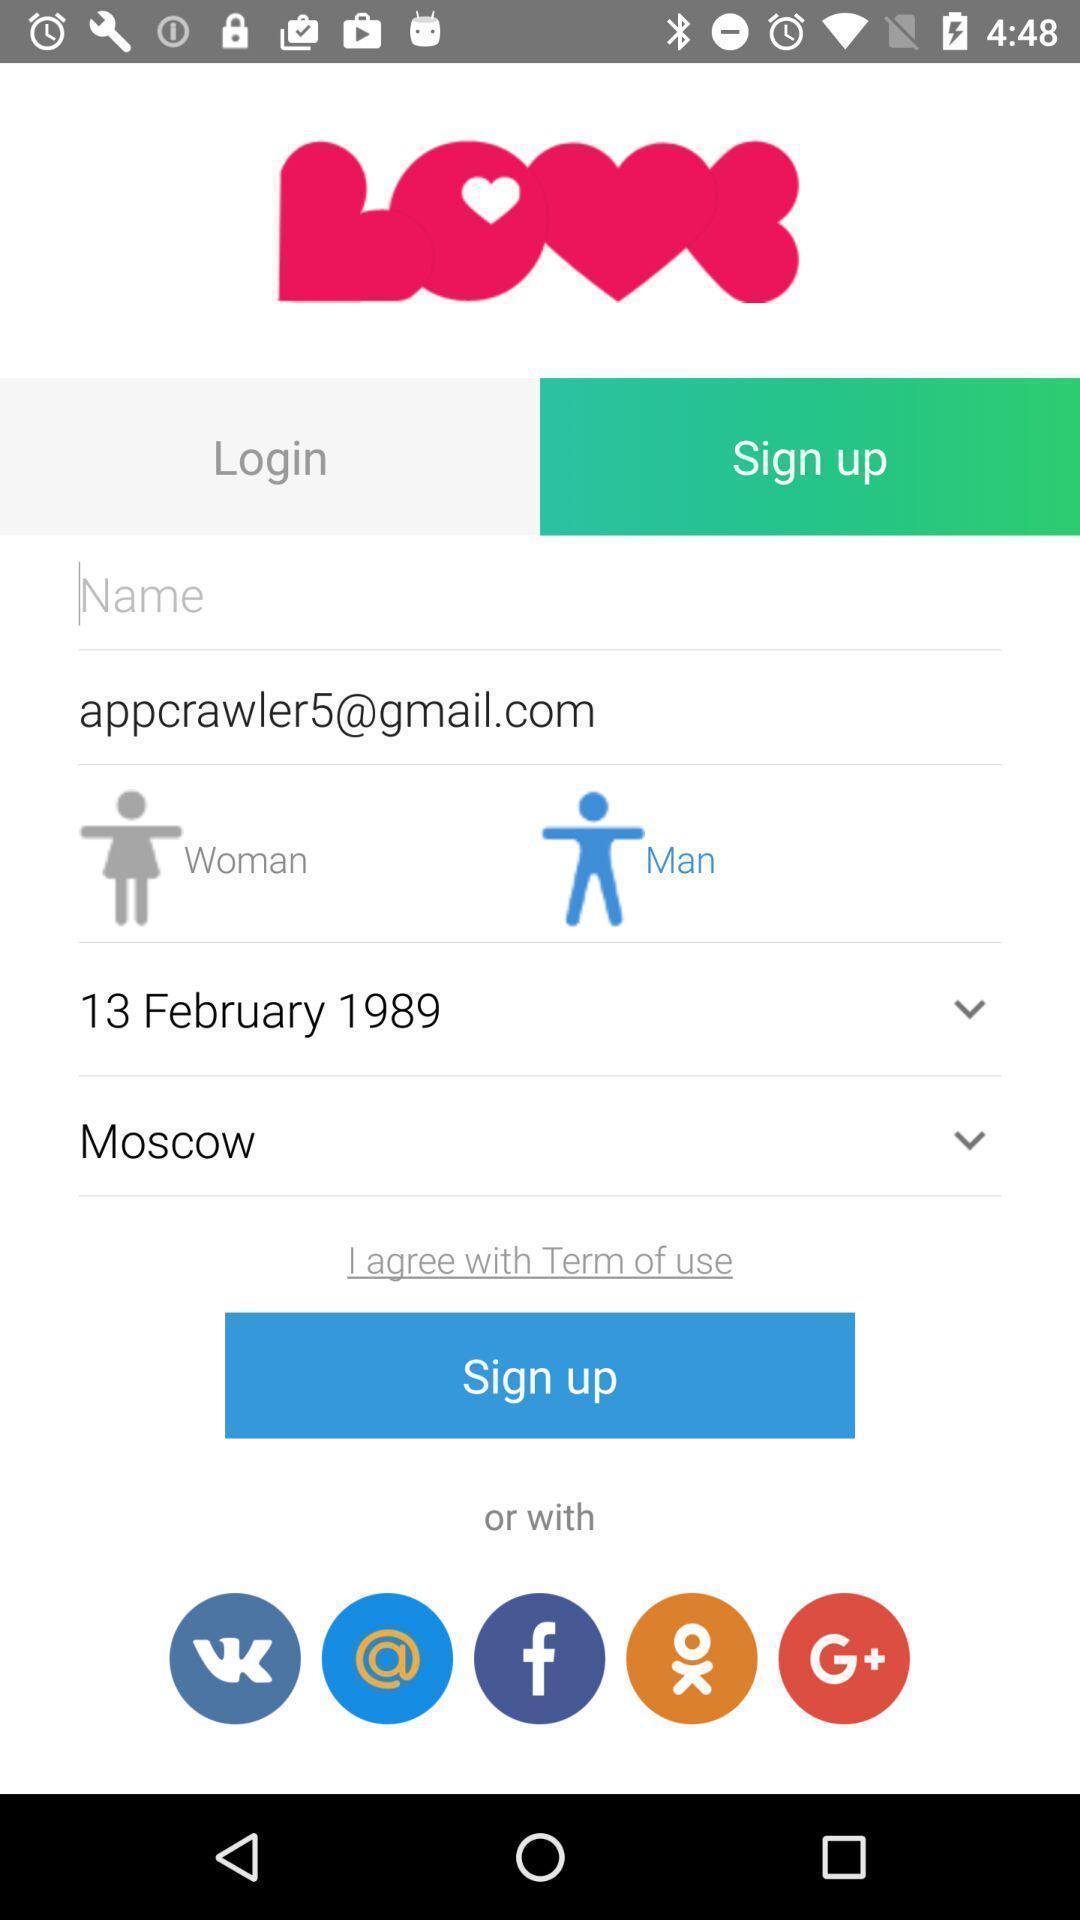Summarize the information in this screenshot. Sign up page of an dating application. 